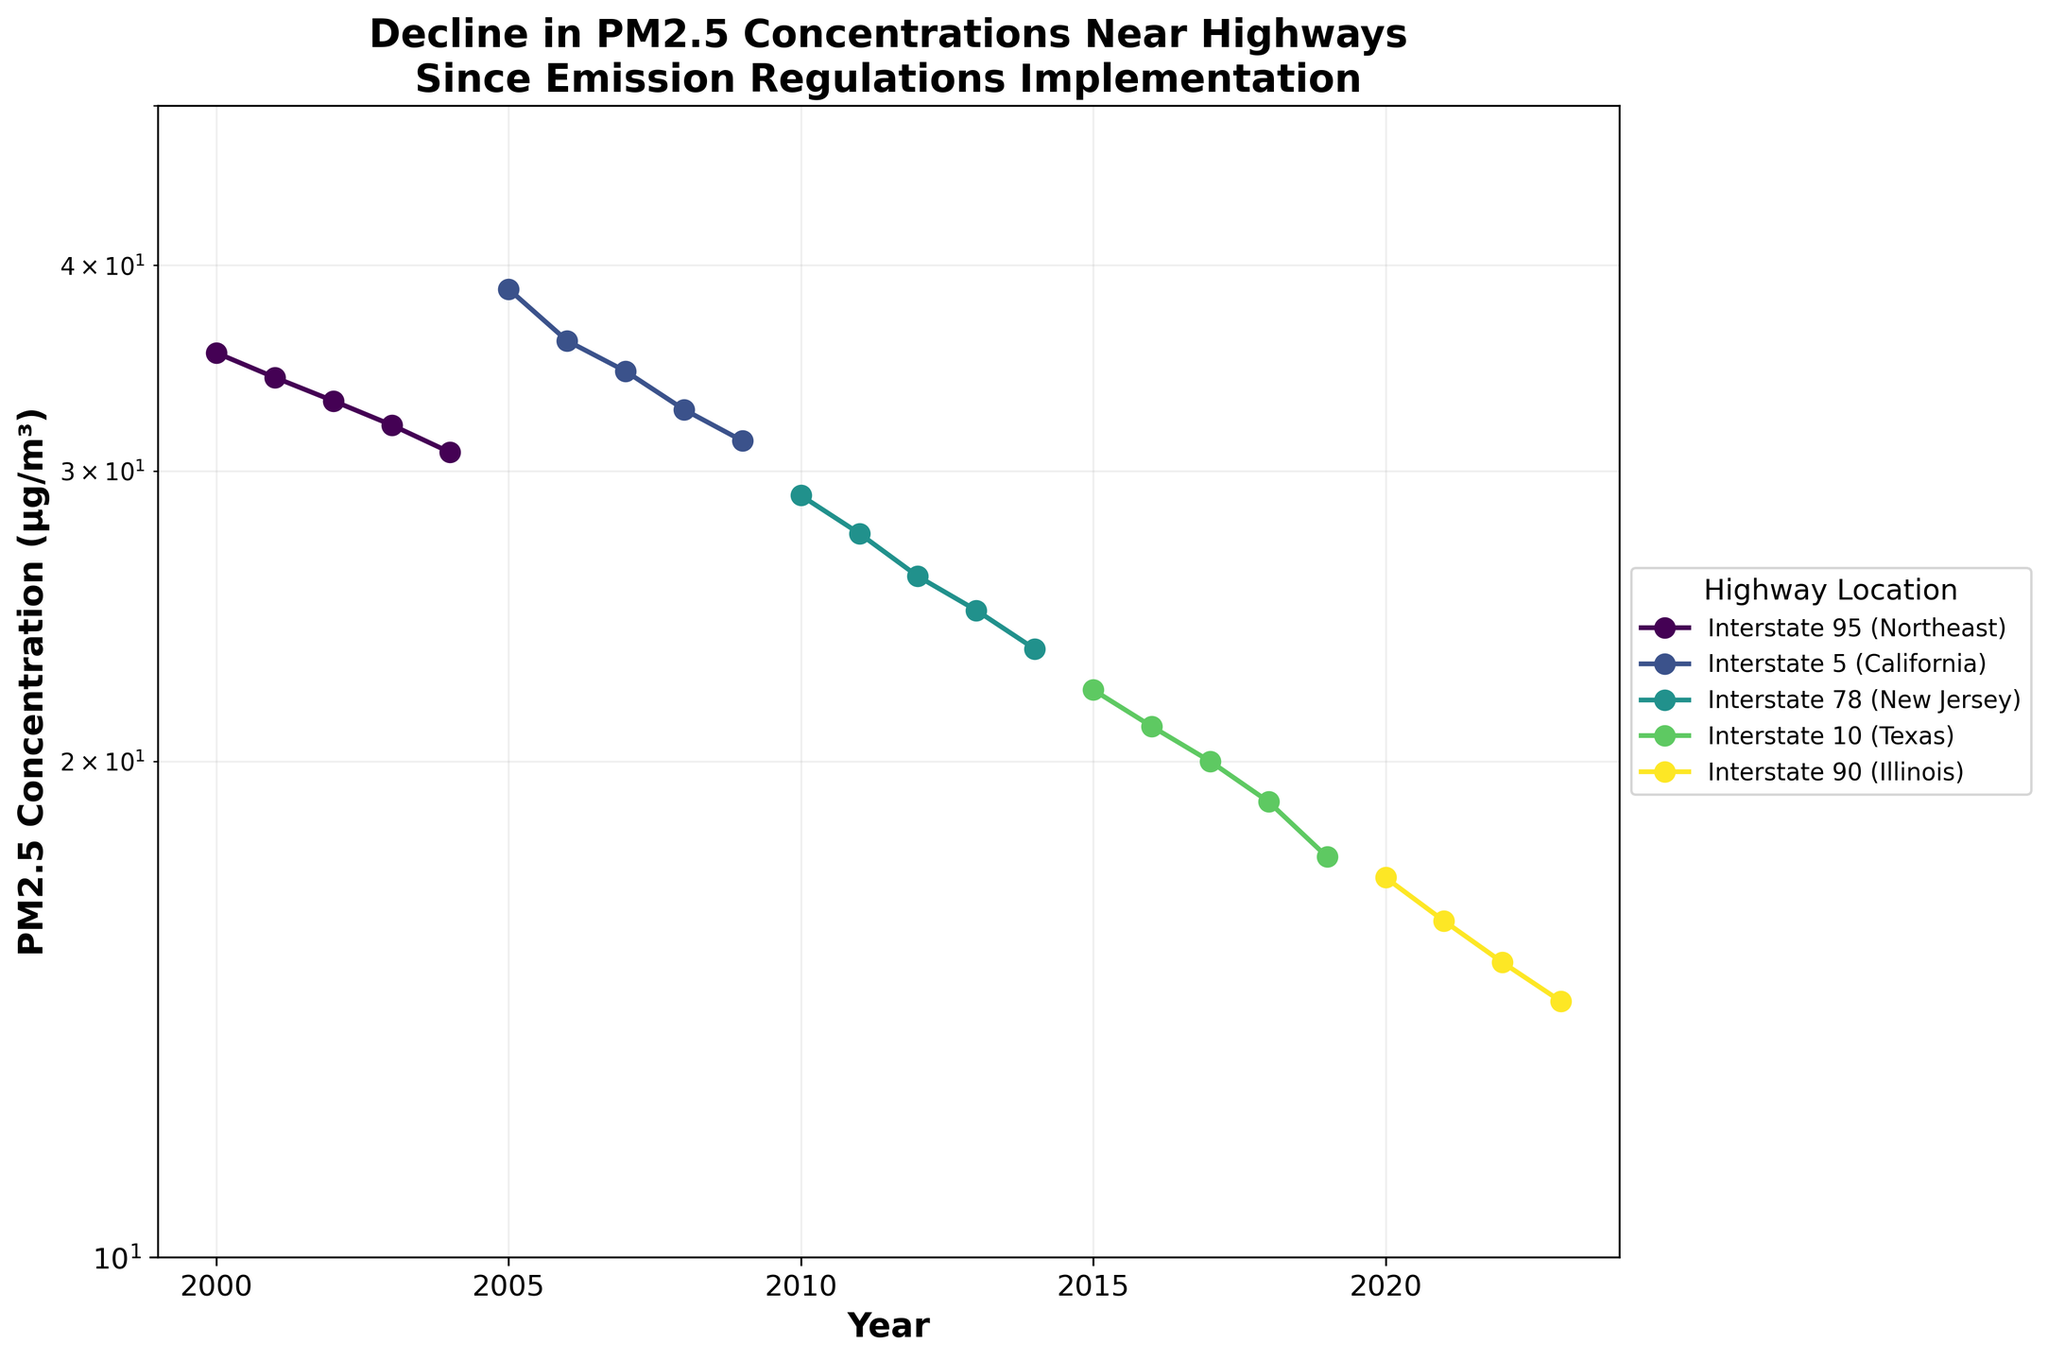What is the title of the plot? The title is usually located at the top of a plot and summarizes what the plot illustrates. In this case, the title states: 'Decline in PM2.5 Concentrations Near Highways Since Emission Regulations Implementation'
Answer: Decline in PM2.5 Concentrations Near Highways Since Emission Regulations Implementation What year does the plot start and end? The x-axis of the plot indicates the time span covered by the data. According to the axis, the plot starts in 2000 and ends in 2023.
Answer: 2000 to 2023 Which highway location had the highest PM2.5 concentration in 2005? To find this, look at the y-axis values for the year 2005, then identify which line (representing a highway location) reaches the highest value. Interstate 5 (California) had the highest PM2.5 concentration in 2005.
Answer: Interstate 5 (California) How many highway locations are represented in the plot? Each color and label in the legend represents a distinct highway location. Counting these labels will give you the total number of locations. There are 5 highway locations represented.
Answer: 5 What is the trend in PM2.5 concentrations for Interstate 10 (Texas) between 2015 and 2019? Observe the line representing Interstate 10 (Texas) and note the changes in y-axis values from 2015 to 2019. The PM2.5 concentration for Interstate 10 (Texas) decreases from 22.1 to 17.5.
Answer: Decreasing What was the approximate PM2.5 concentration for Interstate 90 (Illinois) in 2022? Locate the line for Interstate 90 (Illinois) on the plot and trace its intersection with the y-axis value at the year 2022. The concentration is approximately 15.1 µg/m³ in 2022.
Answer: 15.1 µg/m³ Which highway location shows the most significant decline in PM2.5 concentration over the recorded period? To determine this, identify the line with the steepest overall downward trend from its highest to lowest value. Interstate 5 (California) shows the most significant decline.
Answer: Interstate 5 (California) In 2010, which location had a lower PM2.5 concentration: Interstate 78 (New Jersey) or Interstate 5 (California)? Compare the heights of the two lines at the year 2010. Interstate 78 (New Jersey) had a concentration of 29.0, whereas Interstate 5 (California) had a concentration higher than 29.0. Therefore, Interstate 78 (New Jersey) had a lower concentration.
Answer: Interstate 78 (New Jersey) What is the approximate reduction in PM2.5 concentration for Interstate 95 (Northeast) from 2000 to 2004? Look at the y-axis values at the starting point (2000) and the end point (2004) for the line representing Interstate 95 (Northeast). Subtract the 2004 value (30.8 µg/m³) from the 2000 value (35.4 µg/m³). The reduction is about 4.6 µg/m³.
Answer: 4.6 µg/m³ 